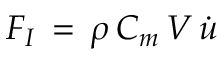<formula> <loc_0><loc_0><loc_500><loc_500>F _ { I } \, = \, \rho \, C _ { m } \, V \, { \dot { u } }</formula> 